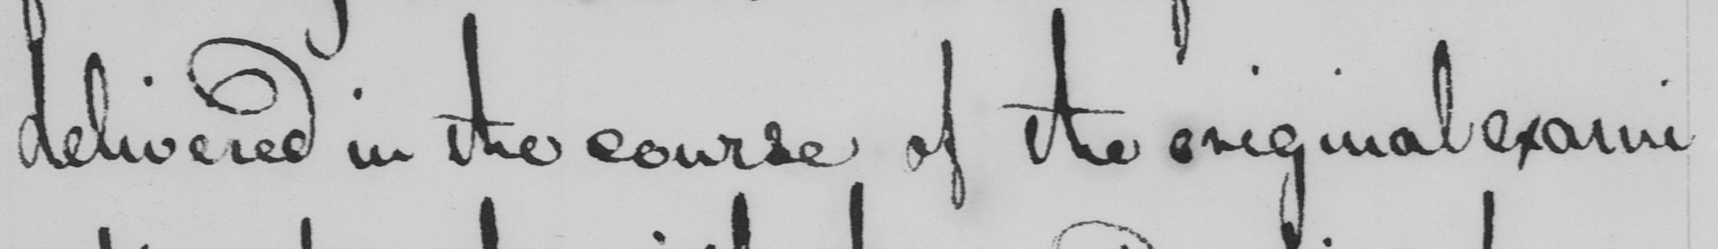Can you read and transcribe this handwriting? delivered in the course of the original exami- 